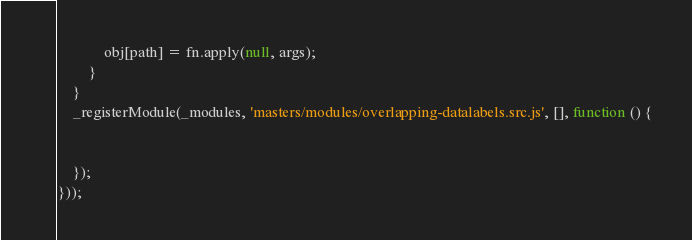Convert code to text. <code><loc_0><loc_0><loc_500><loc_500><_JavaScript_>            obj[path] = fn.apply(null, args);
        }
    }
    _registerModule(_modules, 'masters/modules/overlapping-datalabels.src.js', [], function () {


    });
}));</code> 